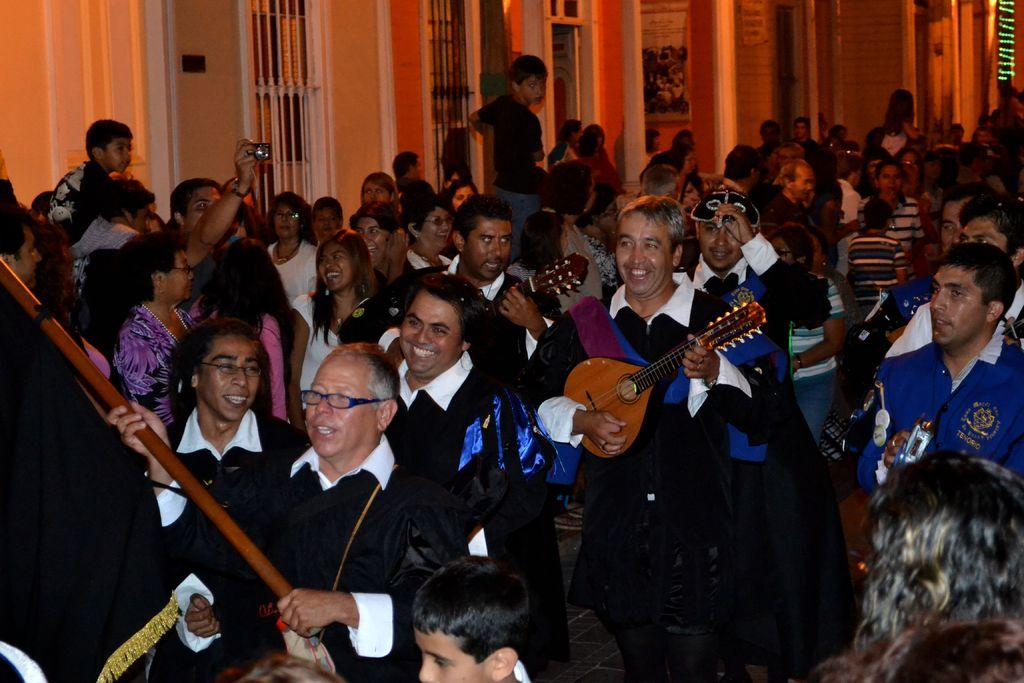What is the person in the image wearing? The person in the image is wearing a black coat. What is the person doing while wearing the black coat? The person is playing a guitar. Who else is present in the image? There are other people in front of the person playing the guitar, and a group of people standing in the background. What type of cable is being used by the person playing the guitar in the image? There is no cable visible in the image; the person is playing an acoustic guitar. How does the behavior of the group of people in the background affect the person playing the guitar? The provided facts do not mention any specific behavior of the group of people in the background, so it is impossible to determine how their behavior might affect the person playing the guitar. 